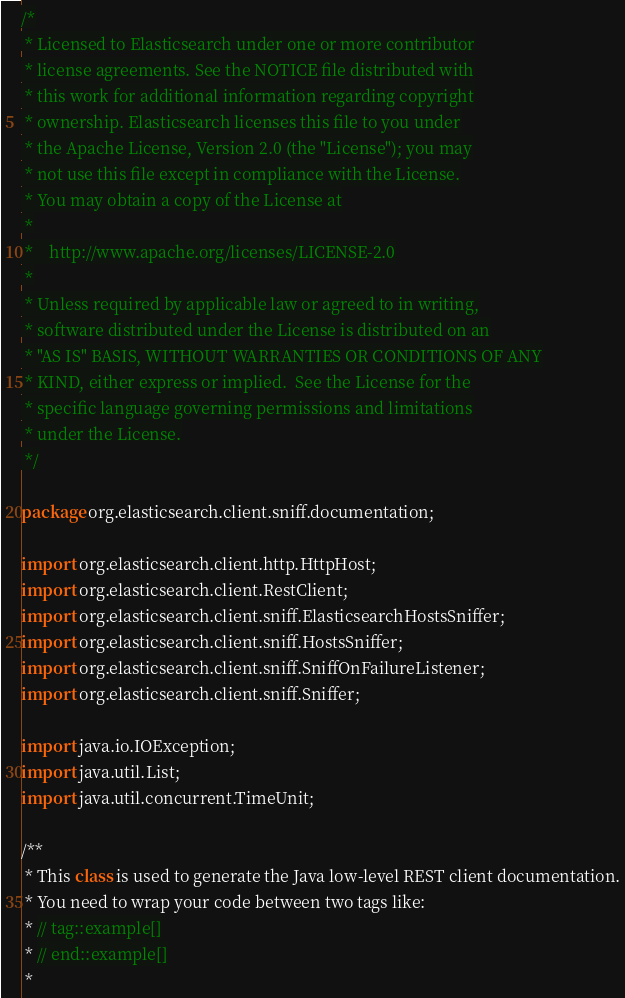Convert code to text. <code><loc_0><loc_0><loc_500><loc_500><_Java_>/*
 * Licensed to Elasticsearch under one or more contributor
 * license agreements. See the NOTICE file distributed with
 * this work for additional information regarding copyright
 * ownership. Elasticsearch licenses this file to you under
 * the Apache License, Version 2.0 (the "License"); you may
 * not use this file except in compliance with the License.
 * You may obtain a copy of the License at
 *
 *    http://www.apache.org/licenses/LICENSE-2.0
 *
 * Unless required by applicable law or agreed to in writing,
 * software distributed under the License is distributed on an
 * "AS IS" BASIS, WITHOUT WARRANTIES OR CONDITIONS OF ANY
 * KIND, either express or implied.  See the License for the
 * specific language governing permissions and limitations
 * under the License.
 */

package org.elasticsearch.client.sniff.documentation;

import org.elasticsearch.client.http.HttpHost;
import org.elasticsearch.client.RestClient;
import org.elasticsearch.client.sniff.ElasticsearchHostsSniffer;
import org.elasticsearch.client.sniff.HostsSniffer;
import org.elasticsearch.client.sniff.SniffOnFailureListener;
import org.elasticsearch.client.sniff.Sniffer;

import java.io.IOException;
import java.util.List;
import java.util.concurrent.TimeUnit;

/**
 * This class is used to generate the Java low-level REST client documentation.
 * You need to wrap your code between two tags like:
 * // tag::example[]
 * // end::example[]
 *</code> 